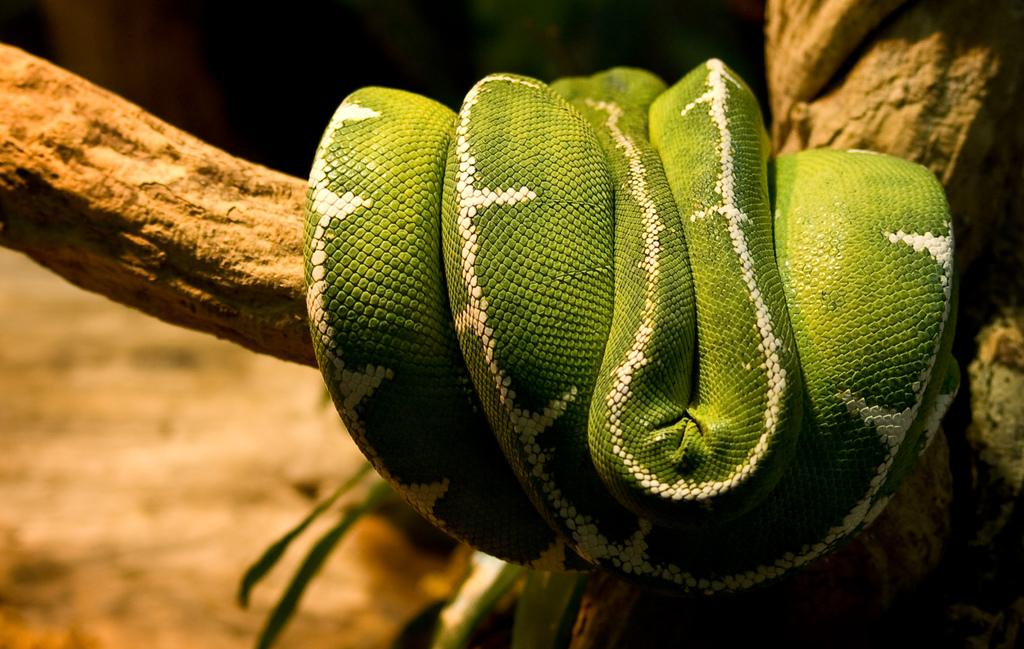What animal can be seen in the image? There is a snake on a branch in the image. How is the snake positioned in the image? The snake is on a branch in the image. What can be observed about the background of the image? The background of the image is blurred. What type of team can be seen participating in a feast in the image? There is no team or feast present in the image; it features a snake on a branch with a blurred background. How many sheep are visible in the image? There are no sheep present in the image. 